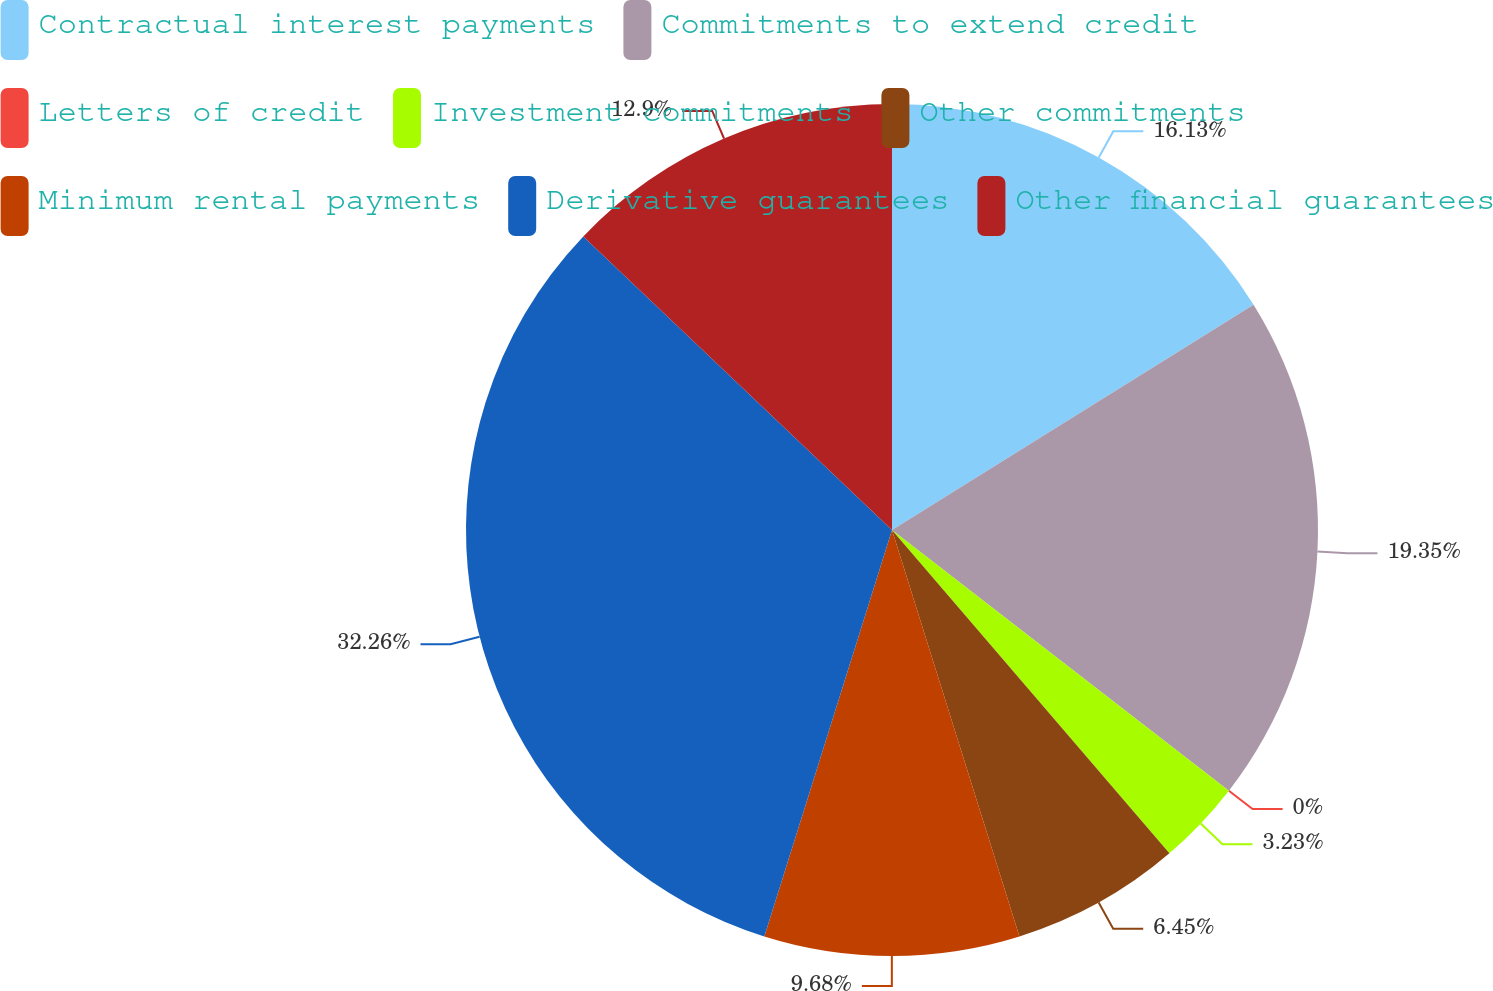<chart> <loc_0><loc_0><loc_500><loc_500><pie_chart><fcel>Contractual interest payments<fcel>Commitments to extend credit<fcel>Letters of credit<fcel>Investment commitments<fcel>Other commitments<fcel>Minimum rental payments<fcel>Derivative guarantees<fcel>Other financial guarantees<nl><fcel>16.13%<fcel>19.35%<fcel>0.0%<fcel>3.23%<fcel>6.45%<fcel>9.68%<fcel>32.25%<fcel>12.9%<nl></chart> 